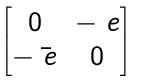<formula> <loc_0><loc_0><loc_500><loc_500>\begin{bmatrix} 0 & - \ e \\ - \bar { \ e } & 0 \end{bmatrix}</formula> 